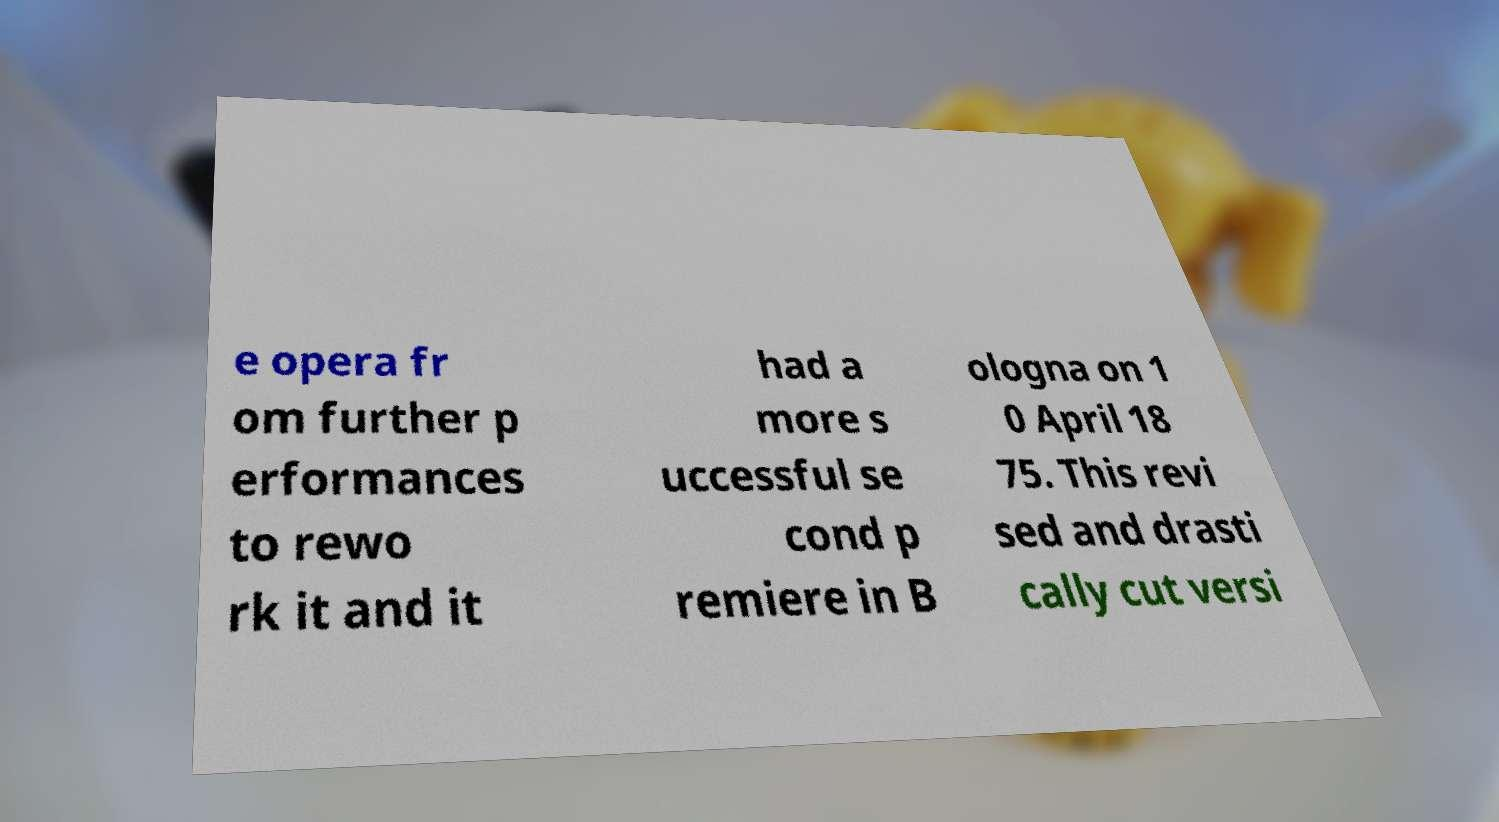For documentation purposes, I need the text within this image transcribed. Could you provide that? e opera fr om further p erformances to rewo rk it and it had a more s uccessful se cond p remiere in B ologna on 1 0 April 18 75. This revi sed and drasti cally cut versi 